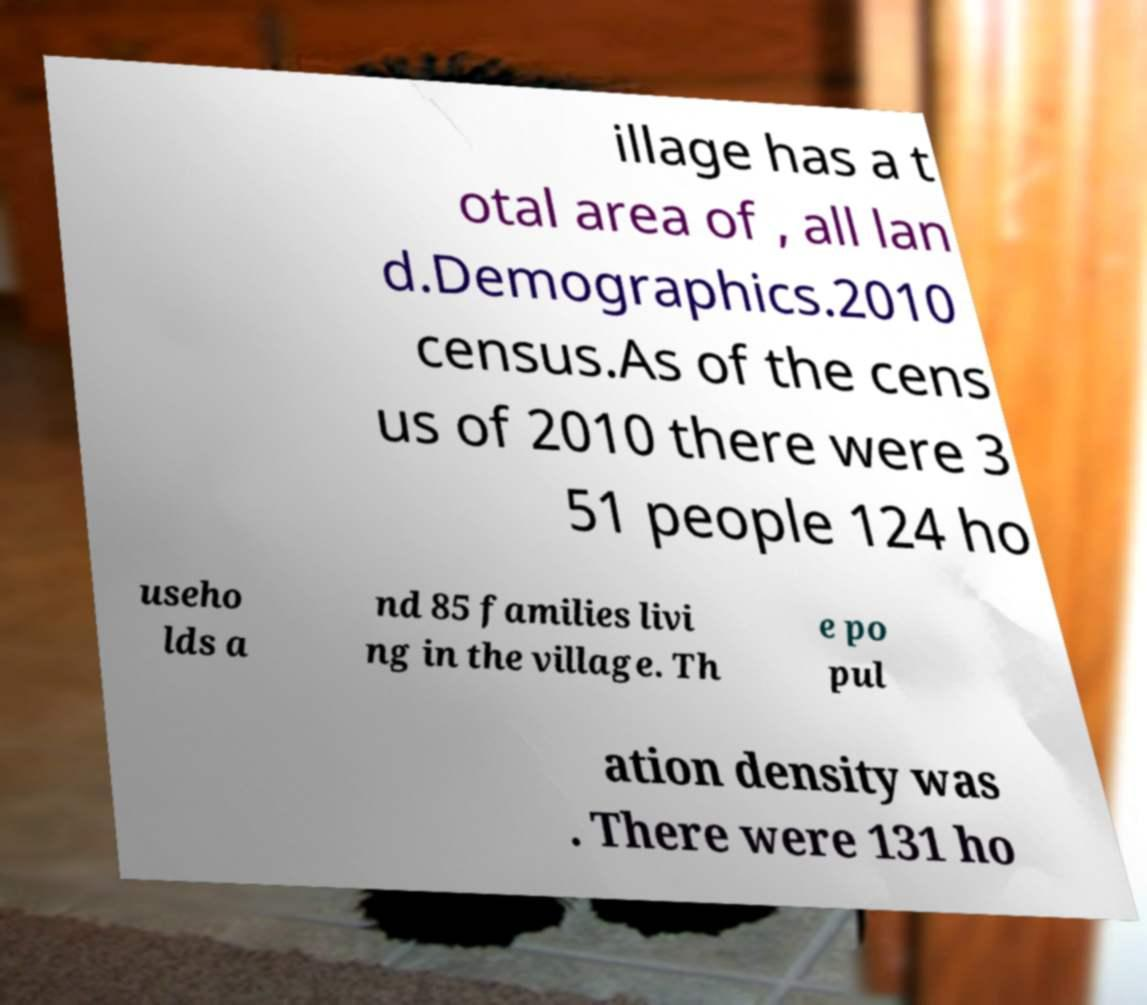Please identify and transcribe the text found in this image. illage has a t otal area of , all lan d.Demographics.2010 census.As of the cens us of 2010 there were 3 51 people 124 ho useho lds a nd 85 families livi ng in the village. Th e po pul ation density was . There were 131 ho 